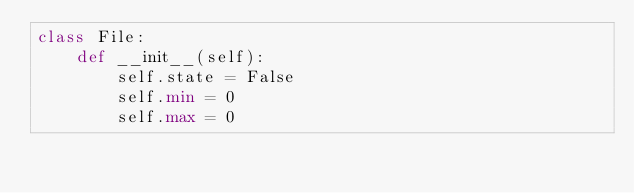Convert code to text. <code><loc_0><loc_0><loc_500><loc_500><_Python_>class File:
    def __init__(self):
        self.state = False
        self.min = 0
        self.max = 0
</code> 